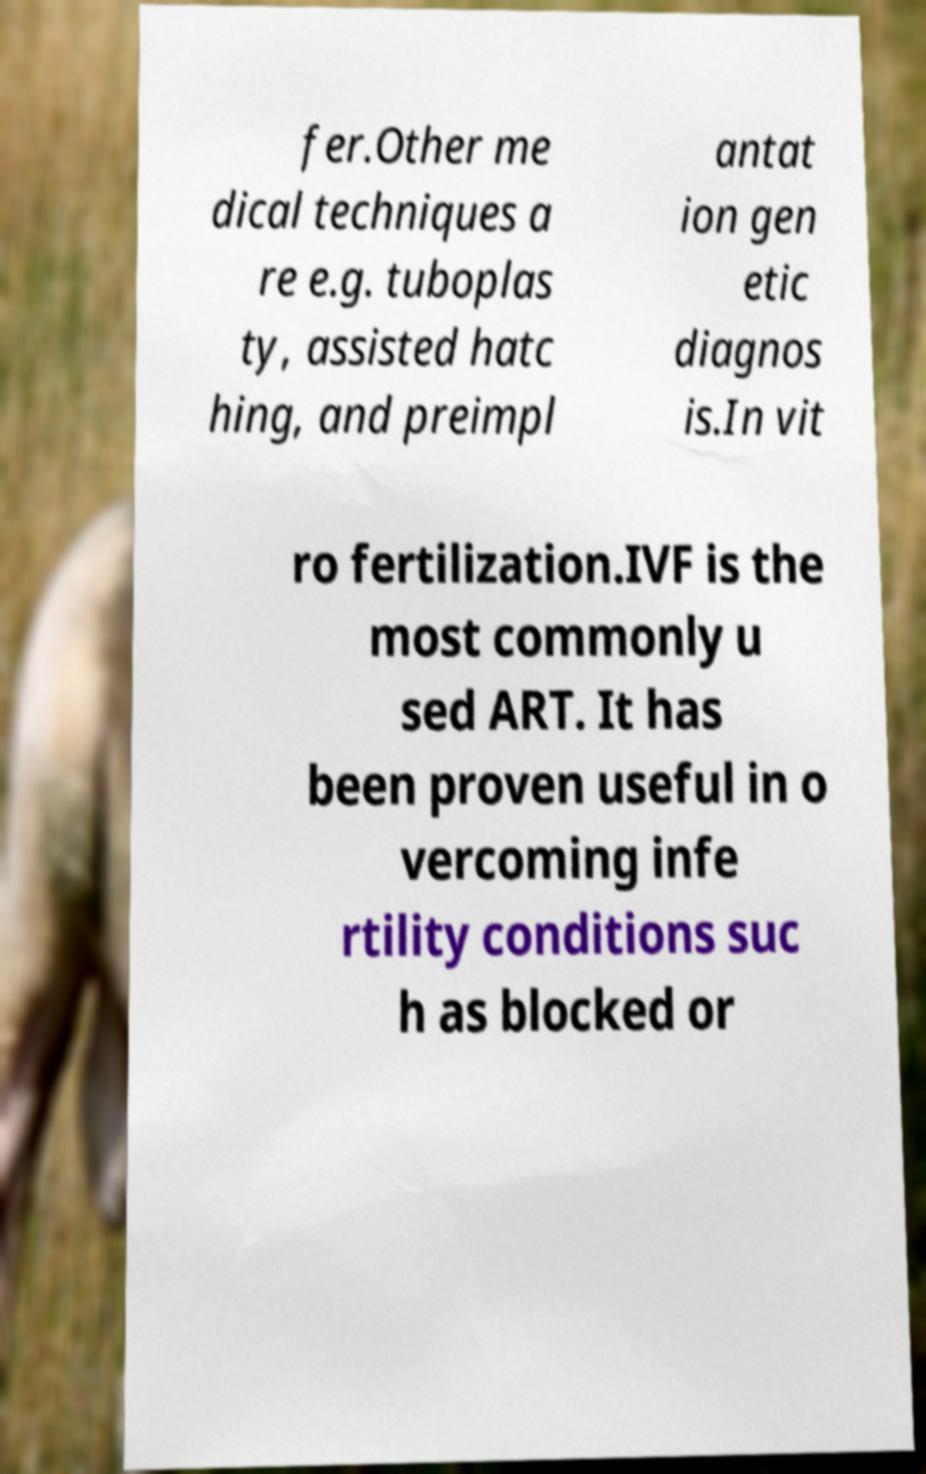Can you accurately transcribe the text from the provided image for me? fer.Other me dical techniques a re e.g. tuboplas ty, assisted hatc hing, and preimpl antat ion gen etic diagnos is.In vit ro fertilization.IVF is the most commonly u sed ART. It has been proven useful in o vercoming infe rtility conditions suc h as blocked or 